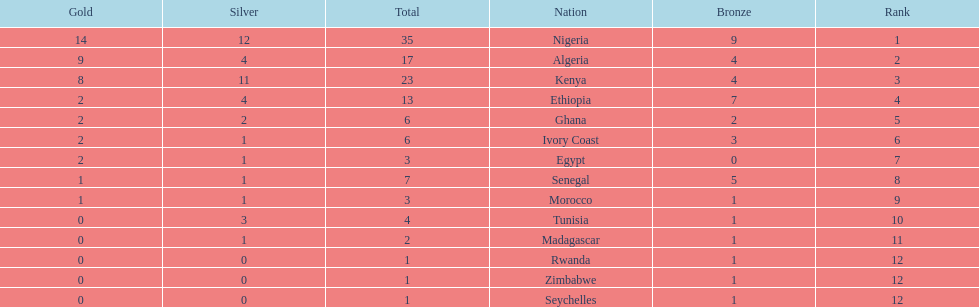What is the name of the only nation that did not earn any bronze medals? Egypt. 